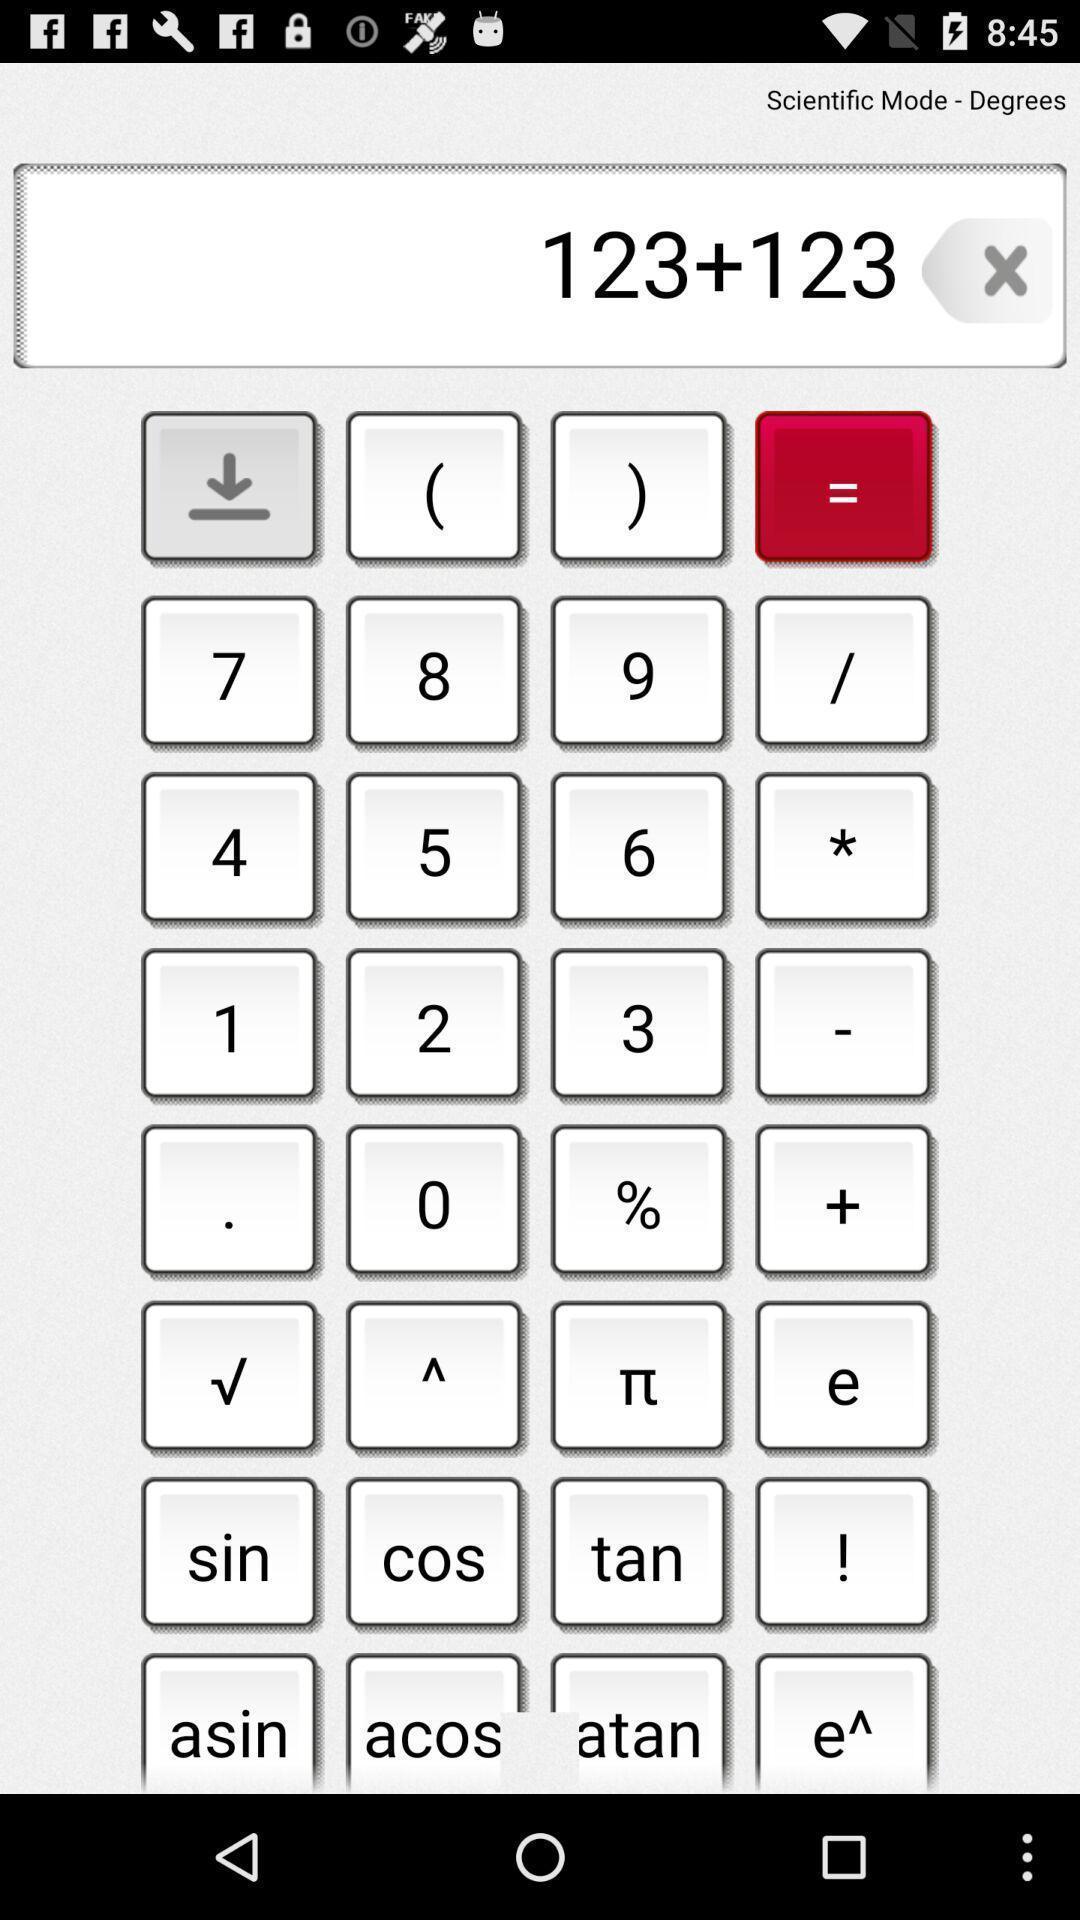Summarize the main components in this picture. Screen shows a mobile calculator. 